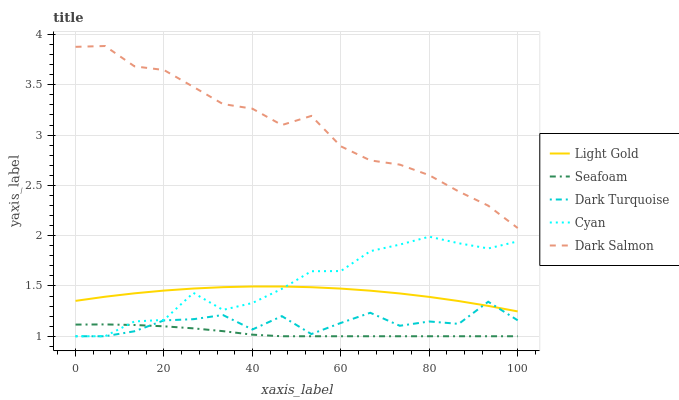Does Seafoam have the minimum area under the curve?
Answer yes or no. Yes. Does Dark Salmon have the maximum area under the curve?
Answer yes or no. Yes. Does Light Gold have the minimum area under the curve?
Answer yes or no. No. Does Light Gold have the maximum area under the curve?
Answer yes or no. No. Is Seafoam the smoothest?
Answer yes or no. Yes. Is Dark Turquoise the roughest?
Answer yes or no. Yes. Is Dark Salmon the smoothest?
Answer yes or no. No. Is Dark Salmon the roughest?
Answer yes or no. No. Does Light Gold have the lowest value?
Answer yes or no. No. Does Light Gold have the highest value?
Answer yes or no. No. Is Light Gold less than Dark Salmon?
Answer yes or no. Yes. Is Dark Salmon greater than Dark Turquoise?
Answer yes or no. Yes. Does Light Gold intersect Dark Salmon?
Answer yes or no. No. 